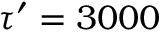<formula> <loc_0><loc_0><loc_500><loc_500>\tau ^ { \prime } = 3 0 0 0</formula> 